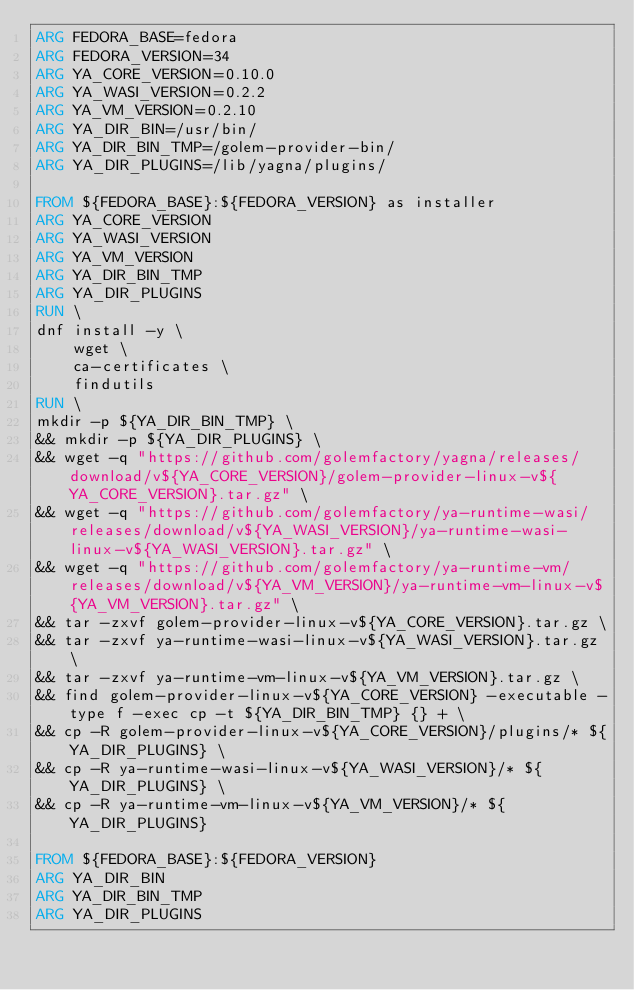<code> <loc_0><loc_0><loc_500><loc_500><_Dockerfile_>ARG FEDORA_BASE=fedora
ARG FEDORA_VERSION=34
ARG YA_CORE_VERSION=0.10.0
ARG YA_WASI_VERSION=0.2.2
ARG YA_VM_VERSION=0.2.10
ARG YA_DIR_BIN=/usr/bin/
ARG YA_DIR_BIN_TMP=/golem-provider-bin/
ARG YA_DIR_PLUGINS=/lib/yagna/plugins/

FROM ${FEDORA_BASE}:${FEDORA_VERSION} as installer
ARG YA_CORE_VERSION
ARG YA_WASI_VERSION
ARG YA_VM_VERSION
ARG YA_DIR_BIN_TMP
ARG YA_DIR_PLUGINS
RUN \
dnf install -y \
    wget \
    ca-certificates \
    findutils
RUN \
mkdir -p ${YA_DIR_BIN_TMP} \
&& mkdir -p ${YA_DIR_PLUGINS} \
&& wget -q "https://github.com/golemfactory/yagna/releases/download/v${YA_CORE_VERSION}/golem-provider-linux-v${YA_CORE_VERSION}.tar.gz" \
&& wget -q "https://github.com/golemfactory/ya-runtime-wasi/releases/download/v${YA_WASI_VERSION}/ya-runtime-wasi-linux-v${YA_WASI_VERSION}.tar.gz" \
&& wget -q "https://github.com/golemfactory/ya-runtime-vm/releases/download/v${YA_VM_VERSION}/ya-runtime-vm-linux-v${YA_VM_VERSION}.tar.gz" \
&& tar -zxvf golem-provider-linux-v${YA_CORE_VERSION}.tar.gz \
&& tar -zxvf ya-runtime-wasi-linux-v${YA_WASI_VERSION}.tar.gz \
&& tar -zxvf ya-runtime-vm-linux-v${YA_VM_VERSION}.tar.gz \
&& find golem-provider-linux-v${YA_CORE_VERSION} -executable -type f -exec cp -t ${YA_DIR_BIN_TMP} {} + \
&& cp -R golem-provider-linux-v${YA_CORE_VERSION}/plugins/* ${YA_DIR_PLUGINS} \
&& cp -R ya-runtime-wasi-linux-v${YA_WASI_VERSION}/* ${YA_DIR_PLUGINS} \
&& cp -R ya-runtime-vm-linux-v${YA_VM_VERSION}/* ${YA_DIR_PLUGINS}

FROM ${FEDORA_BASE}:${FEDORA_VERSION}
ARG YA_DIR_BIN
ARG YA_DIR_BIN_TMP
ARG YA_DIR_PLUGINS</code> 